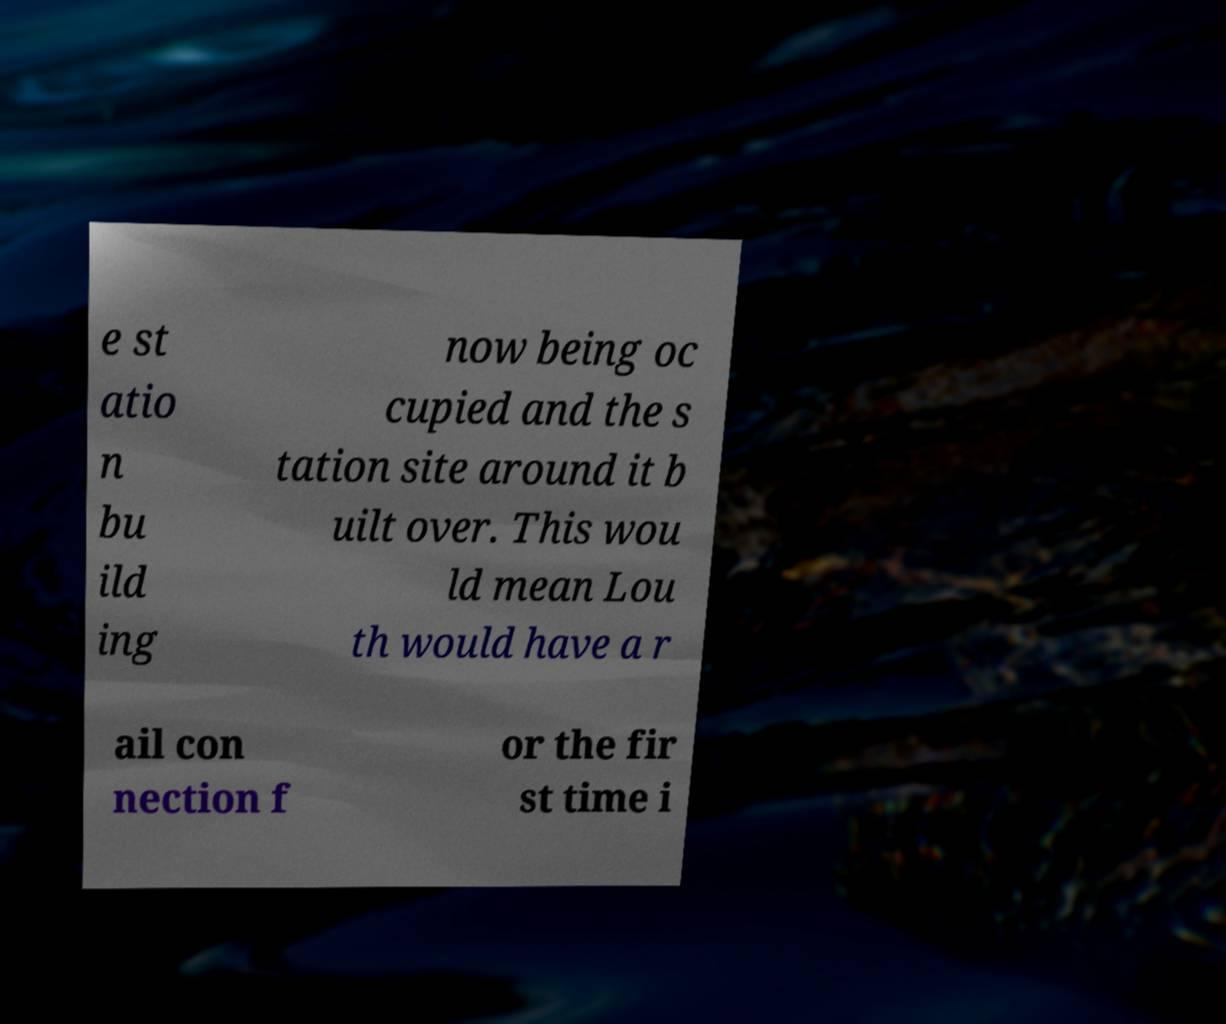Could you assist in decoding the text presented in this image and type it out clearly? e st atio n bu ild ing now being oc cupied and the s tation site around it b uilt over. This wou ld mean Lou th would have a r ail con nection f or the fir st time i 